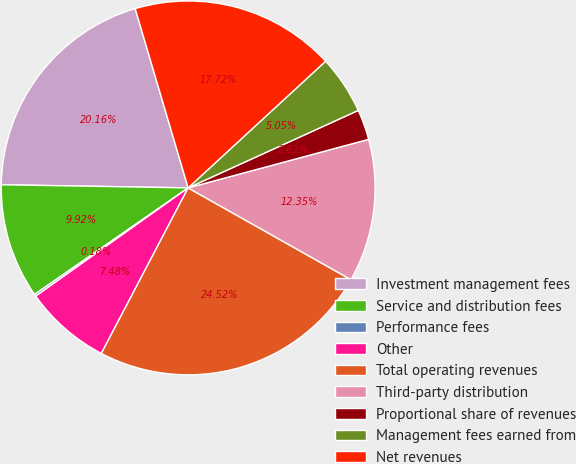<chart> <loc_0><loc_0><loc_500><loc_500><pie_chart><fcel>Investment management fees<fcel>Service and distribution fees<fcel>Performance fees<fcel>Other<fcel>Total operating revenues<fcel>Third-party distribution<fcel>Proportional share of revenues<fcel>Management fees earned from<fcel>Net revenues<nl><fcel>20.16%<fcel>9.92%<fcel>0.18%<fcel>7.48%<fcel>24.52%<fcel>12.35%<fcel>2.62%<fcel>5.05%<fcel>17.72%<nl></chart> 